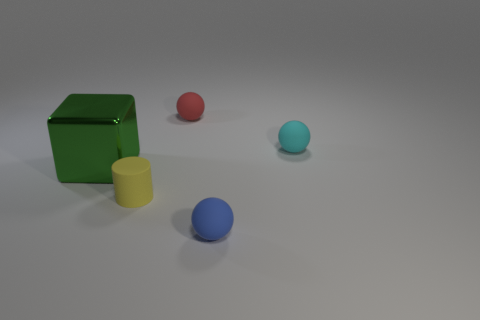Do the sphere behind the cyan thing and the tiny cyan ball have the same material?
Offer a terse response. Yes. There is a thing that is to the right of the blue thing; what is its material?
Keep it short and to the point. Rubber. How big is the ball that is left of the small matte sphere that is in front of the cylinder?
Your response must be concise. Small. What number of blocks are the same size as the yellow matte cylinder?
Offer a very short reply. 0. Do the thing right of the blue ball and the small matte ball in front of the large green metallic thing have the same color?
Ensure brevity in your answer.  No. There is a tiny yellow matte cylinder; are there any tiny cyan rubber balls in front of it?
Your response must be concise. No. There is a thing that is in front of the large shiny object and left of the tiny red matte thing; what color is it?
Ensure brevity in your answer.  Yellow. Is there a small object of the same color as the large metallic cube?
Keep it short and to the point. No. Do the ball in front of the cyan sphere and the sphere that is behind the tiny cyan object have the same material?
Ensure brevity in your answer.  Yes. There is a sphere that is in front of the metal thing; what is its size?
Provide a short and direct response. Small. 